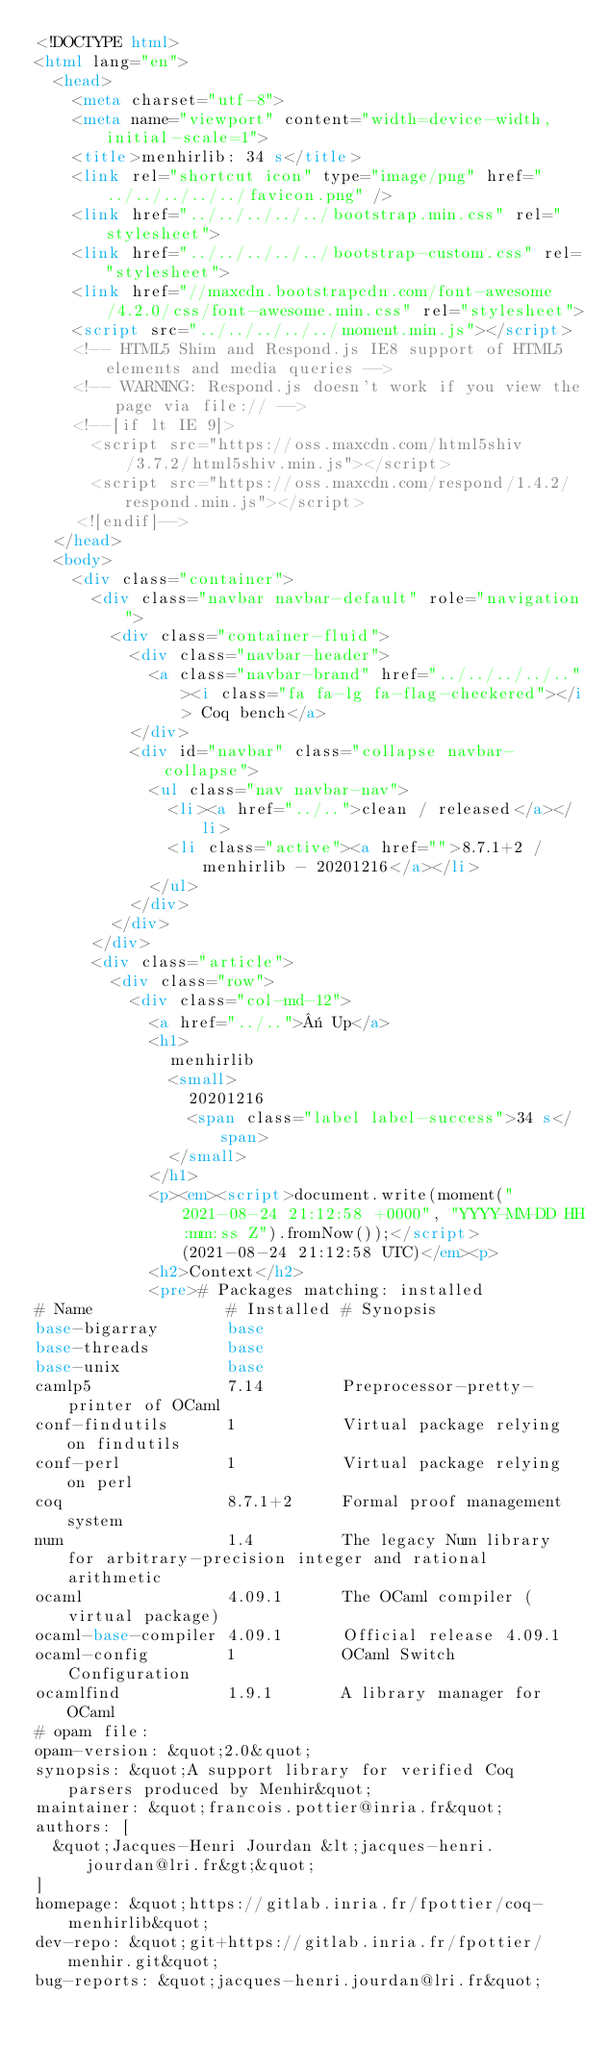<code> <loc_0><loc_0><loc_500><loc_500><_HTML_><!DOCTYPE html>
<html lang="en">
  <head>
    <meta charset="utf-8">
    <meta name="viewport" content="width=device-width, initial-scale=1">
    <title>menhirlib: 34 s</title>
    <link rel="shortcut icon" type="image/png" href="../../../../../favicon.png" />
    <link href="../../../../../bootstrap.min.css" rel="stylesheet">
    <link href="../../../../../bootstrap-custom.css" rel="stylesheet">
    <link href="//maxcdn.bootstrapcdn.com/font-awesome/4.2.0/css/font-awesome.min.css" rel="stylesheet">
    <script src="../../../../../moment.min.js"></script>
    <!-- HTML5 Shim and Respond.js IE8 support of HTML5 elements and media queries -->
    <!-- WARNING: Respond.js doesn't work if you view the page via file:// -->
    <!--[if lt IE 9]>
      <script src="https://oss.maxcdn.com/html5shiv/3.7.2/html5shiv.min.js"></script>
      <script src="https://oss.maxcdn.com/respond/1.4.2/respond.min.js"></script>
    <![endif]-->
  </head>
  <body>
    <div class="container">
      <div class="navbar navbar-default" role="navigation">
        <div class="container-fluid">
          <div class="navbar-header">
            <a class="navbar-brand" href="../../../../.."><i class="fa fa-lg fa-flag-checkered"></i> Coq bench</a>
          </div>
          <div id="navbar" class="collapse navbar-collapse">
            <ul class="nav navbar-nav">
              <li><a href="../..">clean / released</a></li>
              <li class="active"><a href="">8.7.1+2 / menhirlib - 20201216</a></li>
            </ul>
          </div>
        </div>
      </div>
      <div class="article">
        <div class="row">
          <div class="col-md-12">
            <a href="../..">« Up</a>
            <h1>
              menhirlib
              <small>
                20201216
                <span class="label label-success">34 s</span>
              </small>
            </h1>
            <p><em><script>document.write(moment("2021-08-24 21:12:58 +0000", "YYYY-MM-DD HH:mm:ss Z").fromNow());</script> (2021-08-24 21:12:58 UTC)</em><p>
            <h2>Context</h2>
            <pre># Packages matching: installed
# Name              # Installed # Synopsis
base-bigarray       base
base-threads        base
base-unix           base
camlp5              7.14        Preprocessor-pretty-printer of OCaml
conf-findutils      1           Virtual package relying on findutils
conf-perl           1           Virtual package relying on perl
coq                 8.7.1+2     Formal proof management system
num                 1.4         The legacy Num library for arbitrary-precision integer and rational arithmetic
ocaml               4.09.1      The OCaml compiler (virtual package)
ocaml-base-compiler 4.09.1      Official release 4.09.1
ocaml-config        1           OCaml Switch Configuration
ocamlfind           1.9.1       A library manager for OCaml
# opam file:
opam-version: &quot;2.0&quot;
synopsis: &quot;A support library for verified Coq parsers produced by Menhir&quot;
maintainer: &quot;francois.pottier@inria.fr&quot;
authors: [
  &quot;Jacques-Henri Jourdan &lt;jacques-henri.jourdan@lri.fr&gt;&quot;
]
homepage: &quot;https://gitlab.inria.fr/fpottier/coq-menhirlib&quot;
dev-repo: &quot;git+https://gitlab.inria.fr/fpottier/menhir.git&quot;
bug-reports: &quot;jacques-henri.jourdan@lri.fr&quot;</code> 